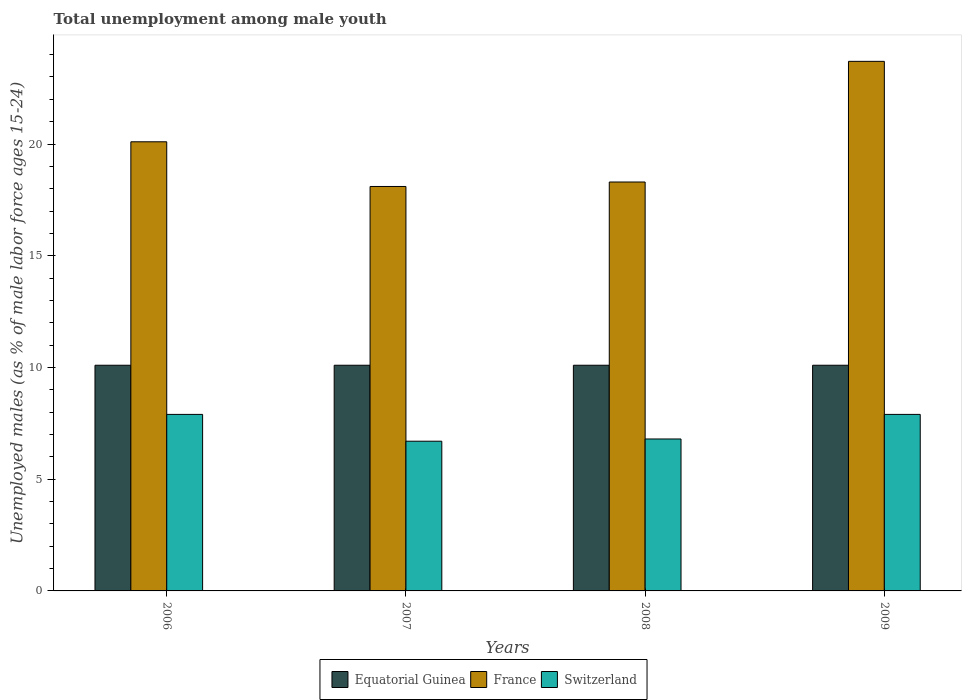How many groups of bars are there?
Offer a terse response. 4. How many bars are there on the 4th tick from the left?
Offer a terse response. 3. How many bars are there on the 1st tick from the right?
Provide a short and direct response. 3. What is the percentage of unemployed males in in Equatorial Guinea in 2006?
Your answer should be very brief. 10.1. Across all years, what is the maximum percentage of unemployed males in in Switzerland?
Offer a very short reply. 7.9. Across all years, what is the minimum percentage of unemployed males in in France?
Make the answer very short. 18.1. In which year was the percentage of unemployed males in in France maximum?
Make the answer very short. 2009. In which year was the percentage of unemployed males in in France minimum?
Your response must be concise. 2007. What is the total percentage of unemployed males in in France in the graph?
Keep it short and to the point. 80.2. What is the difference between the percentage of unemployed males in in France in 2006 and that in 2007?
Provide a short and direct response. 2. What is the difference between the percentage of unemployed males in in Equatorial Guinea in 2007 and the percentage of unemployed males in in France in 2009?
Ensure brevity in your answer.  -13.6. What is the average percentage of unemployed males in in Equatorial Guinea per year?
Provide a succinct answer. 10.1. In the year 2006, what is the difference between the percentage of unemployed males in in Equatorial Guinea and percentage of unemployed males in in France?
Make the answer very short. -10. Is the percentage of unemployed males in in France in 2007 less than that in 2008?
Make the answer very short. Yes. What is the difference between the highest and the second highest percentage of unemployed males in in France?
Offer a very short reply. 3.6. Is the sum of the percentage of unemployed males in in Equatorial Guinea in 2006 and 2009 greater than the maximum percentage of unemployed males in in Switzerland across all years?
Your response must be concise. Yes. What does the 1st bar from the left in 2007 represents?
Your answer should be compact. Equatorial Guinea. What does the 3rd bar from the right in 2007 represents?
Provide a succinct answer. Equatorial Guinea. How many bars are there?
Make the answer very short. 12. How many years are there in the graph?
Offer a very short reply. 4. What is the difference between two consecutive major ticks on the Y-axis?
Your answer should be very brief. 5. Does the graph contain any zero values?
Ensure brevity in your answer.  No. Does the graph contain grids?
Offer a very short reply. No. How many legend labels are there?
Ensure brevity in your answer.  3. What is the title of the graph?
Your response must be concise. Total unemployment among male youth. Does "Hong Kong" appear as one of the legend labels in the graph?
Offer a very short reply. No. What is the label or title of the X-axis?
Your answer should be compact. Years. What is the label or title of the Y-axis?
Give a very brief answer. Unemployed males (as % of male labor force ages 15-24). What is the Unemployed males (as % of male labor force ages 15-24) of Equatorial Guinea in 2006?
Give a very brief answer. 10.1. What is the Unemployed males (as % of male labor force ages 15-24) in France in 2006?
Offer a terse response. 20.1. What is the Unemployed males (as % of male labor force ages 15-24) in Switzerland in 2006?
Offer a very short reply. 7.9. What is the Unemployed males (as % of male labor force ages 15-24) in Equatorial Guinea in 2007?
Offer a terse response. 10.1. What is the Unemployed males (as % of male labor force ages 15-24) in France in 2007?
Ensure brevity in your answer.  18.1. What is the Unemployed males (as % of male labor force ages 15-24) in Switzerland in 2007?
Offer a very short reply. 6.7. What is the Unemployed males (as % of male labor force ages 15-24) in Equatorial Guinea in 2008?
Provide a short and direct response. 10.1. What is the Unemployed males (as % of male labor force ages 15-24) of France in 2008?
Provide a short and direct response. 18.3. What is the Unemployed males (as % of male labor force ages 15-24) of Switzerland in 2008?
Your response must be concise. 6.8. What is the Unemployed males (as % of male labor force ages 15-24) in Equatorial Guinea in 2009?
Offer a terse response. 10.1. What is the Unemployed males (as % of male labor force ages 15-24) in France in 2009?
Offer a very short reply. 23.7. What is the Unemployed males (as % of male labor force ages 15-24) in Switzerland in 2009?
Your answer should be compact. 7.9. Across all years, what is the maximum Unemployed males (as % of male labor force ages 15-24) of Equatorial Guinea?
Your response must be concise. 10.1. Across all years, what is the maximum Unemployed males (as % of male labor force ages 15-24) in France?
Make the answer very short. 23.7. Across all years, what is the maximum Unemployed males (as % of male labor force ages 15-24) of Switzerland?
Ensure brevity in your answer.  7.9. Across all years, what is the minimum Unemployed males (as % of male labor force ages 15-24) of Equatorial Guinea?
Your response must be concise. 10.1. Across all years, what is the minimum Unemployed males (as % of male labor force ages 15-24) in France?
Offer a terse response. 18.1. Across all years, what is the minimum Unemployed males (as % of male labor force ages 15-24) of Switzerland?
Offer a terse response. 6.7. What is the total Unemployed males (as % of male labor force ages 15-24) in Equatorial Guinea in the graph?
Offer a very short reply. 40.4. What is the total Unemployed males (as % of male labor force ages 15-24) of France in the graph?
Provide a short and direct response. 80.2. What is the total Unemployed males (as % of male labor force ages 15-24) in Switzerland in the graph?
Provide a short and direct response. 29.3. What is the difference between the Unemployed males (as % of male labor force ages 15-24) of France in 2006 and that in 2007?
Keep it short and to the point. 2. What is the difference between the Unemployed males (as % of male labor force ages 15-24) in Switzerland in 2006 and that in 2007?
Your answer should be very brief. 1.2. What is the difference between the Unemployed males (as % of male labor force ages 15-24) in Equatorial Guinea in 2006 and that in 2008?
Your answer should be compact. 0. What is the difference between the Unemployed males (as % of male labor force ages 15-24) in Switzerland in 2006 and that in 2008?
Keep it short and to the point. 1.1. What is the difference between the Unemployed males (as % of male labor force ages 15-24) in Equatorial Guinea in 2006 and that in 2009?
Give a very brief answer. 0. What is the difference between the Unemployed males (as % of male labor force ages 15-24) of France in 2006 and that in 2009?
Your response must be concise. -3.6. What is the difference between the Unemployed males (as % of male labor force ages 15-24) in Equatorial Guinea in 2007 and that in 2008?
Offer a very short reply. 0. What is the difference between the Unemployed males (as % of male labor force ages 15-24) of Switzerland in 2007 and that in 2008?
Offer a very short reply. -0.1. What is the difference between the Unemployed males (as % of male labor force ages 15-24) of Equatorial Guinea in 2007 and that in 2009?
Ensure brevity in your answer.  0. What is the difference between the Unemployed males (as % of male labor force ages 15-24) of France in 2007 and that in 2009?
Your answer should be very brief. -5.6. What is the difference between the Unemployed males (as % of male labor force ages 15-24) of Switzerland in 2007 and that in 2009?
Make the answer very short. -1.2. What is the difference between the Unemployed males (as % of male labor force ages 15-24) in Equatorial Guinea in 2008 and that in 2009?
Your answer should be very brief. 0. What is the difference between the Unemployed males (as % of male labor force ages 15-24) of France in 2008 and that in 2009?
Offer a very short reply. -5.4. What is the difference between the Unemployed males (as % of male labor force ages 15-24) of Equatorial Guinea in 2006 and the Unemployed males (as % of male labor force ages 15-24) of France in 2007?
Provide a succinct answer. -8. What is the difference between the Unemployed males (as % of male labor force ages 15-24) of Equatorial Guinea in 2006 and the Unemployed males (as % of male labor force ages 15-24) of Switzerland in 2007?
Your answer should be very brief. 3.4. What is the difference between the Unemployed males (as % of male labor force ages 15-24) of France in 2006 and the Unemployed males (as % of male labor force ages 15-24) of Switzerland in 2007?
Keep it short and to the point. 13.4. What is the difference between the Unemployed males (as % of male labor force ages 15-24) of Equatorial Guinea in 2006 and the Unemployed males (as % of male labor force ages 15-24) of France in 2008?
Offer a very short reply. -8.2. What is the difference between the Unemployed males (as % of male labor force ages 15-24) of Equatorial Guinea in 2006 and the Unemployed males (as % of male labor force ages 15-24) of Switzerland in 2008?
Ensure brevity in your answer.  3.3. What is the difference between the Unemployed males (as % of male labor force ages 15-24) in France in 2006 and the Unemployed males (as % of male labor force ages 15-24) in Switzerland in 2008?
Keep it short and to the point. 13.3. What is the difference between the Unemployed males (as % of male labor force ages 15-24) in Equatorial Guinea in 2006 and the Unemployed males (as % of male labor force ages 15-24) in France in 2009?
Offer a terse response. -13.6. What is the difference between the Unemployed males (as % of male labor force ages 15-24) in France in 2006 and the Unemployed males (as % of male labor force ages 15-24) in Switzerland in 2009?
Your response must be concise. 12.2. What is the difference between the Unemployed males (as % of male labor force ages 15-24) of France in 2007 and the Unemployed males (as % of male labor force ages 15-24) of Switzerland in 2008?
Make the answer very short. 11.3. What is the difference between the Unemployed males (as % of male labor force ages 15-24) in Equatorial Guinea in 2007 and the Unemployed males (as % of male labor force ages 15-24) in France in 2009?
Keep it short and to the point. -13.6. What is the difference between the Unemployed males (as % of male labor force ages 15-24) of Equatorial Guinea in 2007 and the Unemployed males (as % of male labor force ages 15-24) of Switzerland in 2009?
Offer a very short reply. 2.2. What is the difference between the Unemployed males (as % of male labor force ages 15-24) of France in 2007 and the Unemployed males (as % of male labor force ages 15-24) of Switzerland in 2009?
Keep it short and to the point. 10.2. What is the difference between the Unemployed males (as % of male labor force ages 15-24) in France in 2008 and the Unemployed males (as % of male labor force ages 15-24) in Switzerland in 2009?
Your response must be concise. 10.4. What is the average Unemployed males (as % of male labor force ages 15-24) of Equatorial Guinea per year?
Your answer should be compact. 10.1. What is the average Unemployed males (as % of male labor force ages 15-24) of France per year?
Provide a short and direct response. 20.05. What is the average Unemployed males (as % of male labor force ages 15-24) of Switzerland per year?
Keep it short and to the point. 7.33. In the year 2007, what is the difference between the Unemployed males (as % of male labor force ages 15-24) of Equatorial Guinea and Unemployed males (as % of male labor force ages 15-24) of France?
Your answer should be compact. -8. In the year 2008, what is the difference between the Unemployed males (as % of male labor force ages 15-24) of Equatorial Guinea and Unemployed males (as % of male labor force ages 15-24) of France?
Your answer should be compact. -8.2. In the year 2008, what is the difference between the Unemployed males (as % of male labor force ages 15-24) of Equatorial Guinea and Unemployed males (as % of male labor force ages 15-24) of Switzerland?
Provide a succinct answer. 3.3. In the year 2008, what is the difference between the Unemployed males (as % of male labor force ages 15-24) in France and Unemployed males (as % of male labor force ages 15-24) in Switzerland?
Provide a short and direct response. 11.5. In the year 2009, what is the difference between the Unemployed males (as % of male labor force ages 15-24) of Equatorial Guinea and Unemployed males (as % of male labor force ages 15-24) of Switzerland?
Offer a terse response. 2.2. In the year 2009, what is the difference between the Unemployed males (as % of male labor force ages 15-24) in France and Unemployed males (as % of male labor force ages 15-24) in Switzerland?
Make the answer very short. 15.8. What is the ratio of the Unemployed males (as % of male labor force ages 15-24) of France in 2006 to that in 2007?
Make the answer very short. 1.11. What is the ratio of the Unemployed males (as % of male labor force ages 15-24) in Switzerland in 2006 to that in 2007?
Your response must be concise. 1.18. What is the ratio of the Unemployed males (as % of male labor force ages 15-24) of Equatorial Guinea in 2006 to that in 2008?
Ensure brevity in your answer.  1. What is the ratio of the Unemployed males (as % of male labor force ages 15-24) in France in 2006 to that in 2008?
Your answer should be very brief. 1.1. What is the ratio of the Unemployed males (as % of male labor force ages 15-24) in Switzerland in 2006 to that in 2008?
Offer a terse response. 1.16. What is the ratio of the Unemployed males (as % of male labor force ages 15-24) of France in 2006 to that in 2009?
Make the answer very short. 0.85. What is the ratio of the Unemployed males (as % of male labor force ages 15-24) of France in 2007 to that in 2008?
Give a very brief answer. 0.99. What is the ratio of the Unemployed males (as % of male labor force ages 15-24) in Switzerland in 2007 to that in 2008?
Offer a terse response. 0.99. What is the ratio of the Unemployed males (as % of male labor force ages 15-24) of Equatorial Guinea in 2007 to that in 2009?
Provide a succinct answer. 1. What is the ratio of the Unemployed males (as % of male labor force ages 15-24) in France in 2007 to that in 2009?
Keep it short and to the point. 0.76. What is the ratio of the Unemployed males (as % of male labor force ages 15-24) in Switzerland in 2007 to that in 2009?
Offer a very short reply. 0.85. What is the ratio of the Unemployed males (as % of male labor force ages 15-24) in France in 2008 to that in 2009?
Keep it short and to the point. 0.77. What is the ratio of the Unemployed males (as % of male labor force ages 15-24) in Switzerland in 2008 to that in 2009?
Your answer should be compact. 0.86. What is the difference between the highest and the second highest Unemployed males (as % of male labor force ages 15-24) of France?
Ensure brevity in your answer.  3.6. 